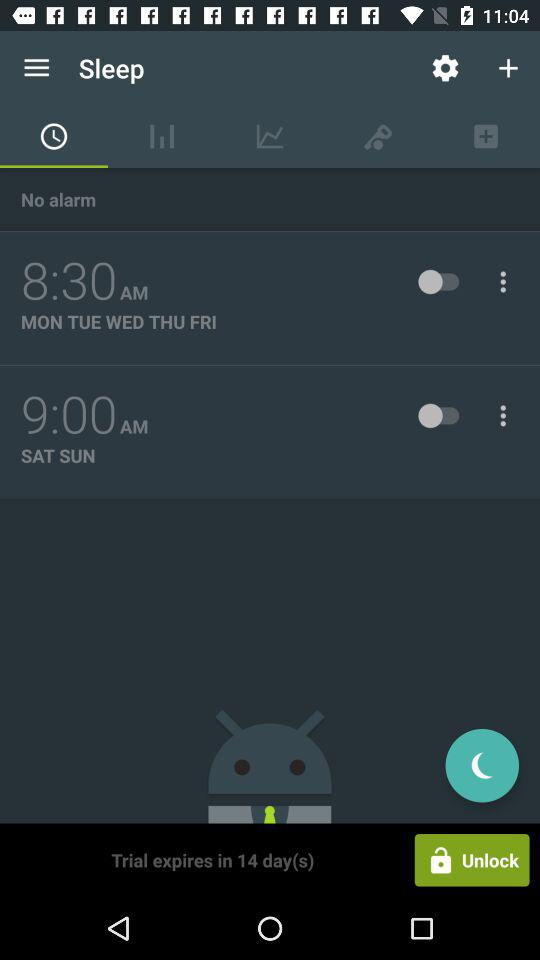What days is the 9:00 AM alarm for? The alarm is for Saturday and Sunday. 